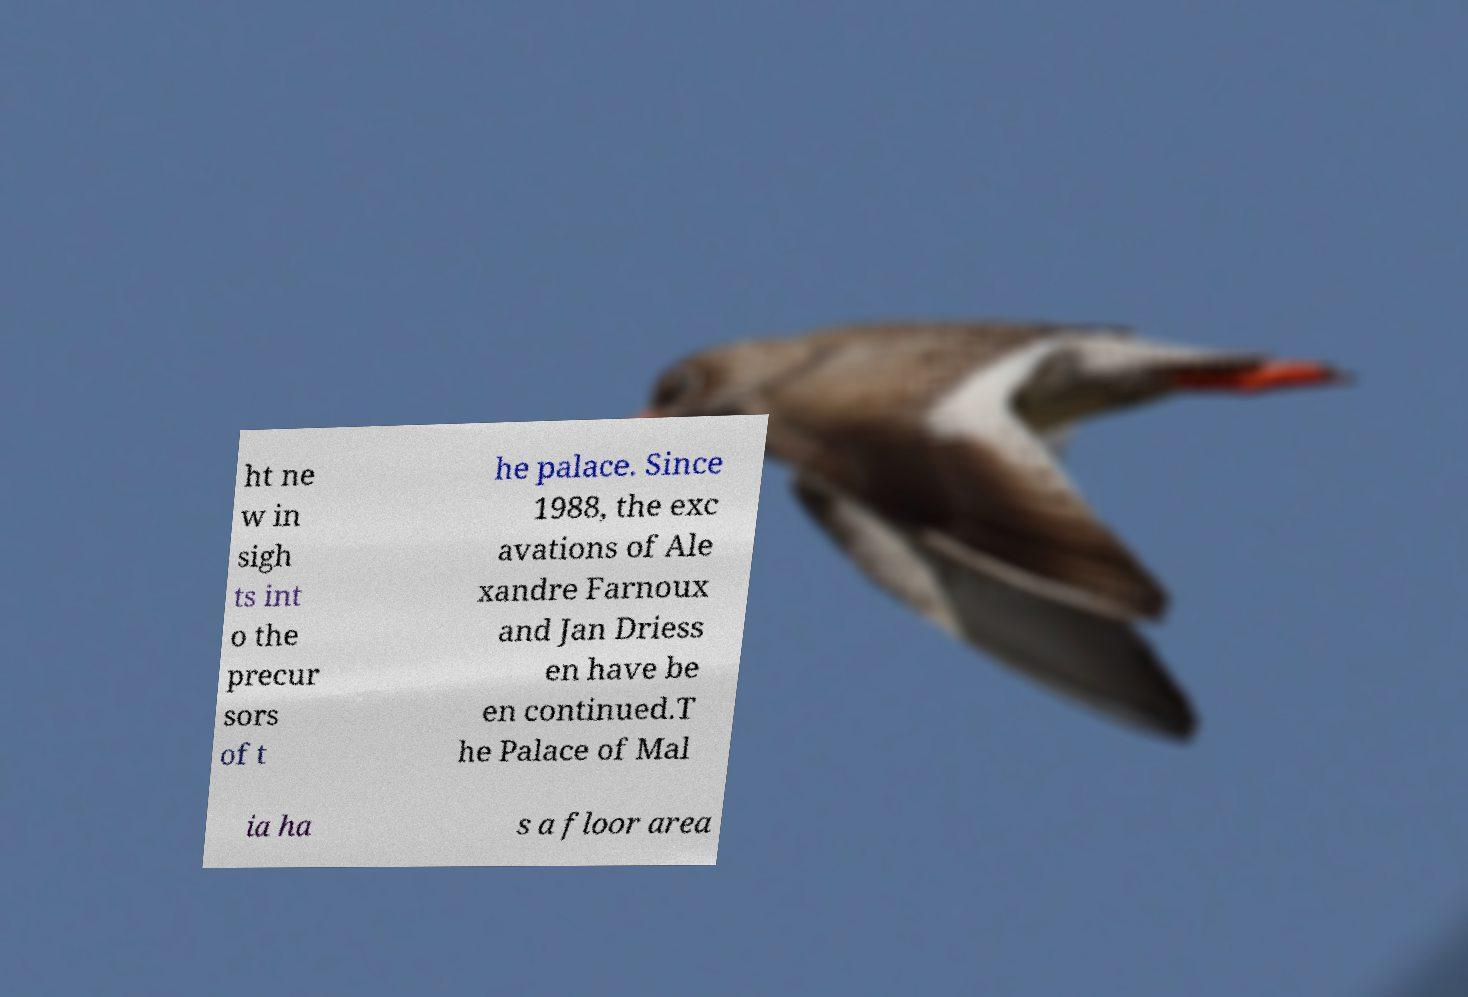What messages or text are displayed in this image? I need them in a readable, typed format. ht ne w in sigh ts int o the precur sors of t he palace. Since 1988, the exc avations of Ale xandre Farnoux and Jan Driess en have be en continued.T he Palace of Mal ia ha s a floor area 